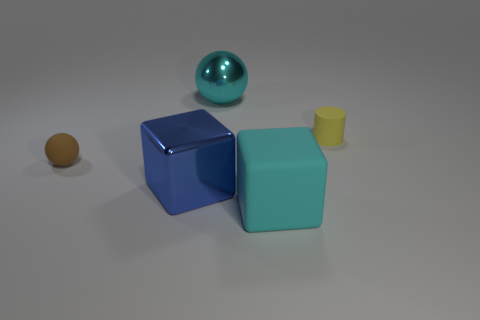How big is the cube left of the big matte block that is to the right of the sphere behind the matte cylinder?
Give a very brief answer. Large. The sphere in front of the metallic thing behind the tiny yellow object is made of what material?
Ensure brevity in your answer.  Rubber. Is there a yellow thing that has the same shape as the large blue metallic thing?
Provide a short and direct response. No. What is the shape of the large blue thing?
Provide a succinct answer. Cube. What is the material of the large cyan block in front of the tiny rubber object that is to the right of the thing that is behind the tiny yellow object?
Your answer should be compact. Rubber. Is the number of yellow rubber cylinders to the left of the small brown rubber object greater than the number of cyan shiny balls?
Provide a succinct answer. No. There is a blue cube that is the same size as the cyan ball; what is its material?
Your answer should be very brief. Metal. Is there a red metallic cylinder that has the same size as the yellow thing?
Your answer should be very brief. No. What size is the metallic object that is behind the tiny brown matte ball?
Your answer should be very brief. Large. What is the size of the yellow thing?
Give a very brief answer. Small. 